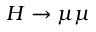Convert formula to latex. <formula><loc_0><loc_0><loc_500><loc_500>H \rightarrow \mu \mu</formula> 